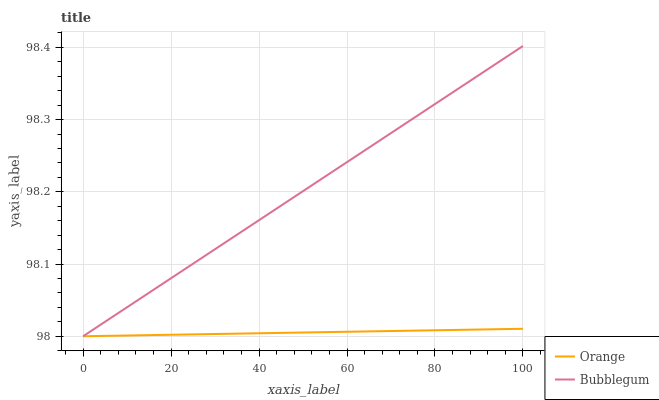Does Orange have the minimum area under the curve?
Answer yes or no. Yes. Does Bubblegum have the maximum area under the curve?
Answer yes or no. Yes. Does Bubblegum have the minimum area under the curve?
Answer yes or no. No. Is Orange the smoothest?
Answer yes or no. Yes. Is Bubblegum the roughest?
Answer yes or no. Yes. Is Bubblegum the smoothest?
Answer yes or no. No. Does Orange have the lowest value?
Answer yes or no. Yes. Does Bubblegum have the highest value?
Answer yes or no. Yes. Does Bubblegum intersect Orange?
Answer yes or no. Yes. Is Bubblegum less than Orange?
Answer yes or no. No. Is Bubblegum greater than Orange?
Answer yes or no. No. 